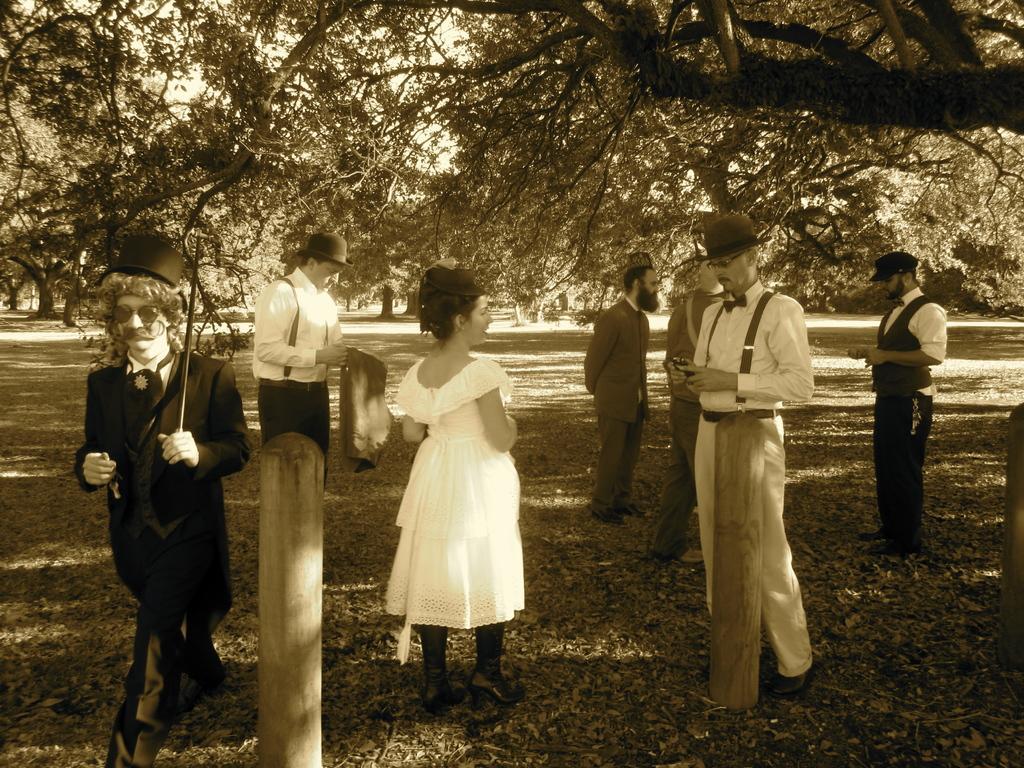How would you summarize this image in a sentence or two? This is a black and white picture. In this picture, we see people are standing. Beside them, we see the poles. At the bottom of the picture, we see dried leaves. There are trees in the background. This picture might be clicked in the park. 